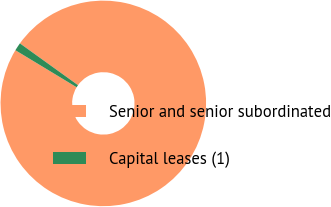Convert chart. <chart><loc_0><loc_0><loc_500><loc_500><pie_chart><fcel>Senior and senior subordinated<fcel>Capital leases (1)<nl><fcel>98.73%<fcel>1.27%<nl></chart> 